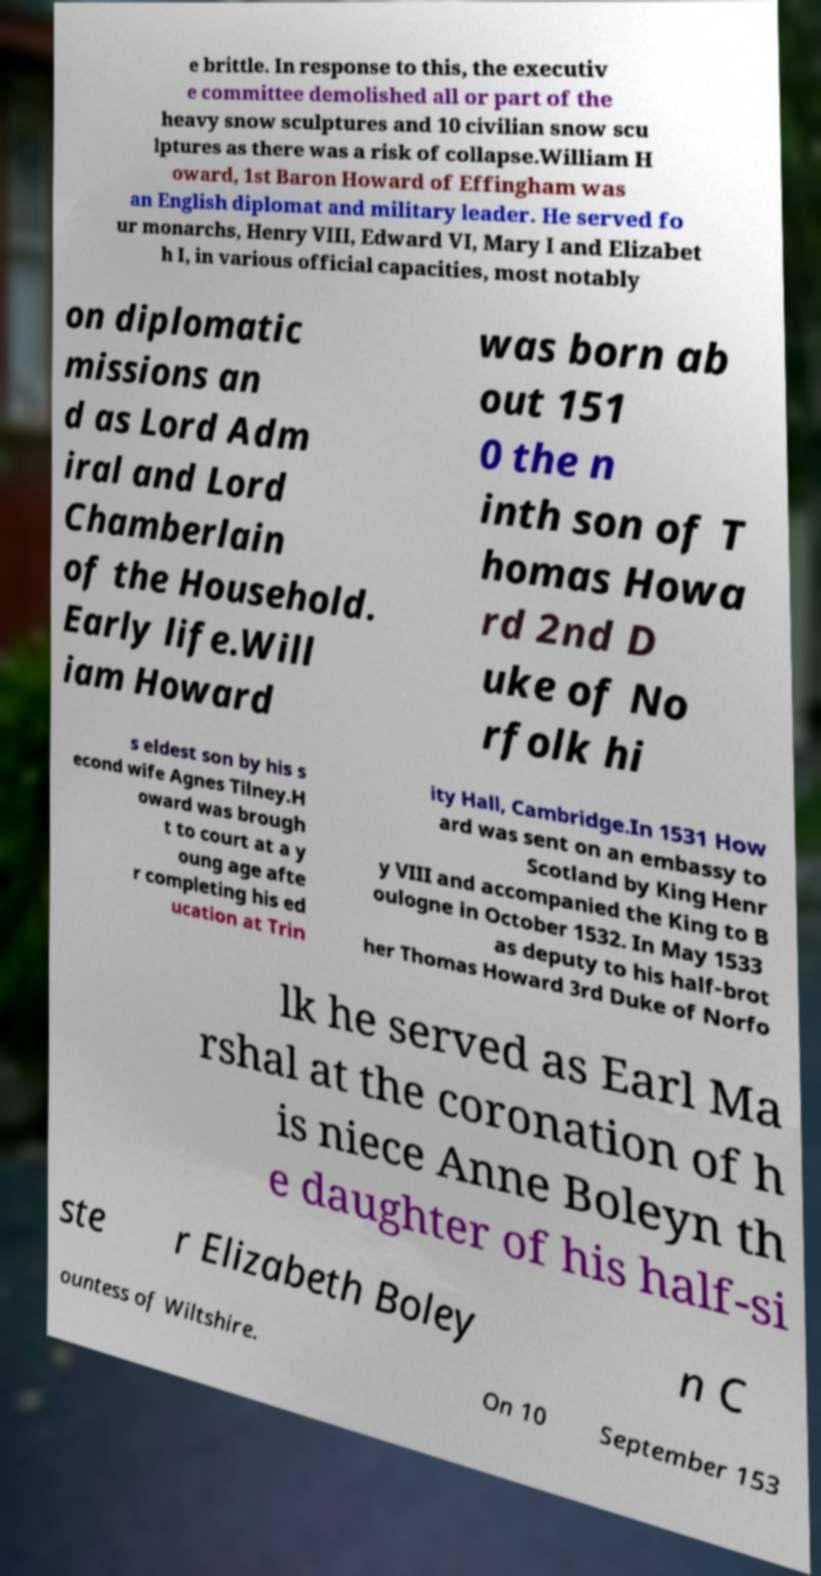Please identify and transcribe the text found in this image. e brittle. In response to this, the executiv e committee demolished all or part of the heavy snow sculptures and 10 civilian snow scu lptures as there was a risk of collapse.William H oward, 1st Baron Howard of Effingham was an English diplomat and military leader. He served fo ur monarchs, Henry VIII, Edward VI, Mary I and Elizabet h I, in various official capacities, most notably on diplomatic missions an d as Lord Adm iral and Lord Chamberlain of the Household. Early life.Will iam Howard was born ab out 151 0 the n inth son of T homas Howa rd 2nd D uke of No rfolk hi s eldest son by his s econd wife Agnes Tilney.H oward was brough t to court at a y oung age afte r completing his ed ucation at Trin ity Hall, Cambridge.In 1531 How ard was sent on an embassy to Scotland by King Henr y VIII and accompanied the King to B oulogne in October 1532. In May 1533 as deputy to his half-brot her Thomas Howard 3rd Duke of Norfo lk he served as Earl Ma rshal at the coronation of h is niece Anne Boleyn th e daughter of his half-si ste r Elizabeth Boley n C ountess of Wiltshire. On 10 September 153 